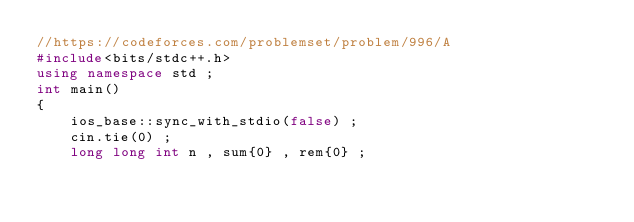Convert code to text. <code><loc_0><loc_0><loc_500><loc_500><_C++_>//https://codeforces.com/problemset/problem/996/A
#include<bits/stdc++.h>
using namespace std ;
int main()
{
    ios_base::sync_with_stdio(false) ;
    cin.tie(0) ;
    long long int n , sum{0} , rem{0} ;</code> 